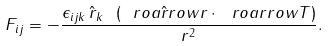<formula> <loc_0><loc_0><loc_500><loc_500>F _ { i j } = - \frac { \epsilon _ { i j k } \, \hat { r } _ { k } \ ( \hat { \ r o a r r o w { r } } \cdot \ r o a r r o w { T } ) } { r ^ { 2 } } .</formula> 